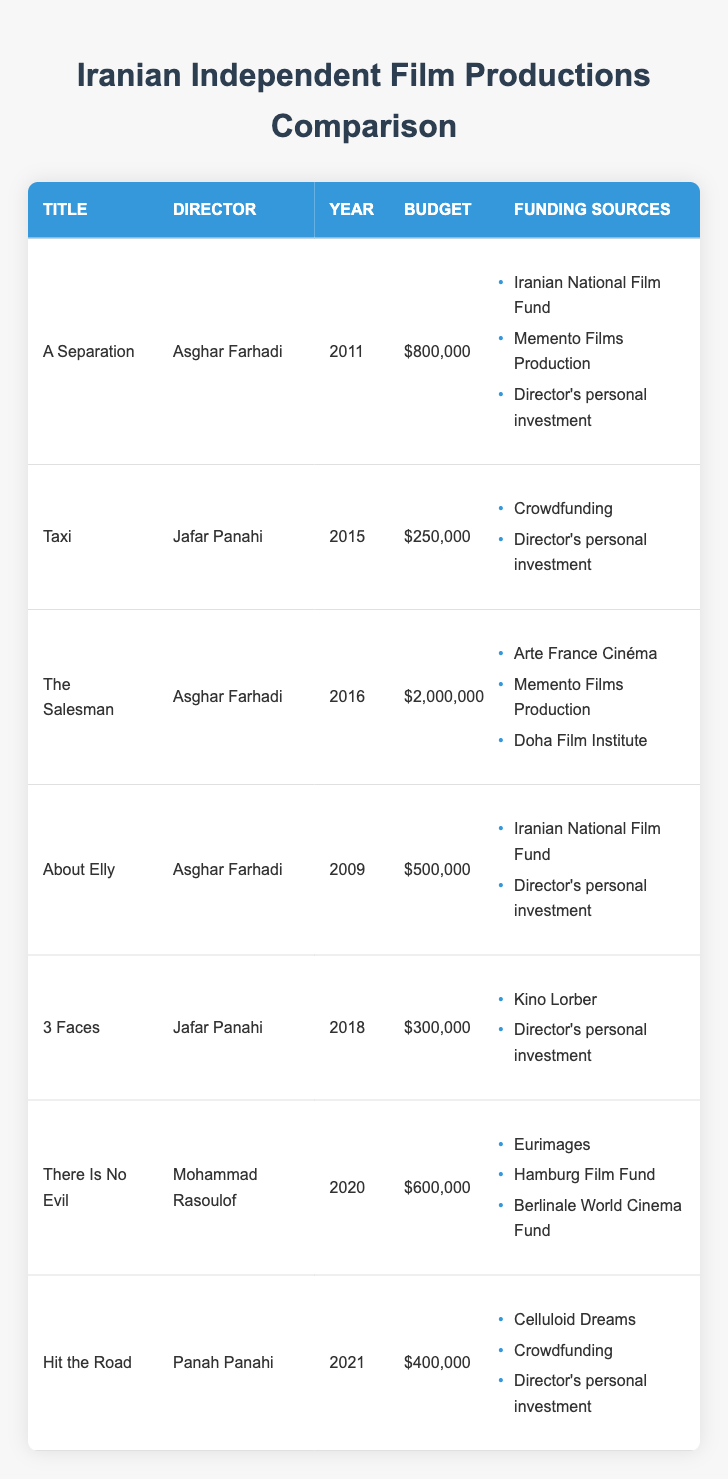What is the budget of "The Salesman"? The table shows the budget for each film. To find the budget for "The Salesman," we locate the row with this title. The corresponding budget entry is $2,000,000.
Answer: $2,000,000 Which film had the lowest budget? We check the budget column for all films and recognize that "Taxi" has the lowest budget of $250,000 compared to the other entries.
Answer: $250,000 Do all films by Asghar Farhadi have funding from the Iranian National Film Fund? We review the films directed by Asghar Farhadi: "A Separation," "About Elly," and "The Salesman." Only "A Separation" and "About Elly" list funding from the Iranian National Film Fund; thus, not all of his films have it.
Answer: No Which directors utilized crowdfunding as a funding source? Looking into the funding sources for each film, "Taxi" and "Hit the Road" mention crowdfunding. This indicates that both Jafar Panahi and Panah Panahi utilized crowdfunding.
Answer: Jafar Panahi and Panah Panahi What is the total budget for films directed by Jafar Panahi? To calculate the total budget for Jafar Panahi's films, we add the budgets of "Taxi" ($250,000) and "3 Faces" ($300,000). Therefore, the total budget is $250,000 + $300,000 = $550,000.
Answer: $550,000 